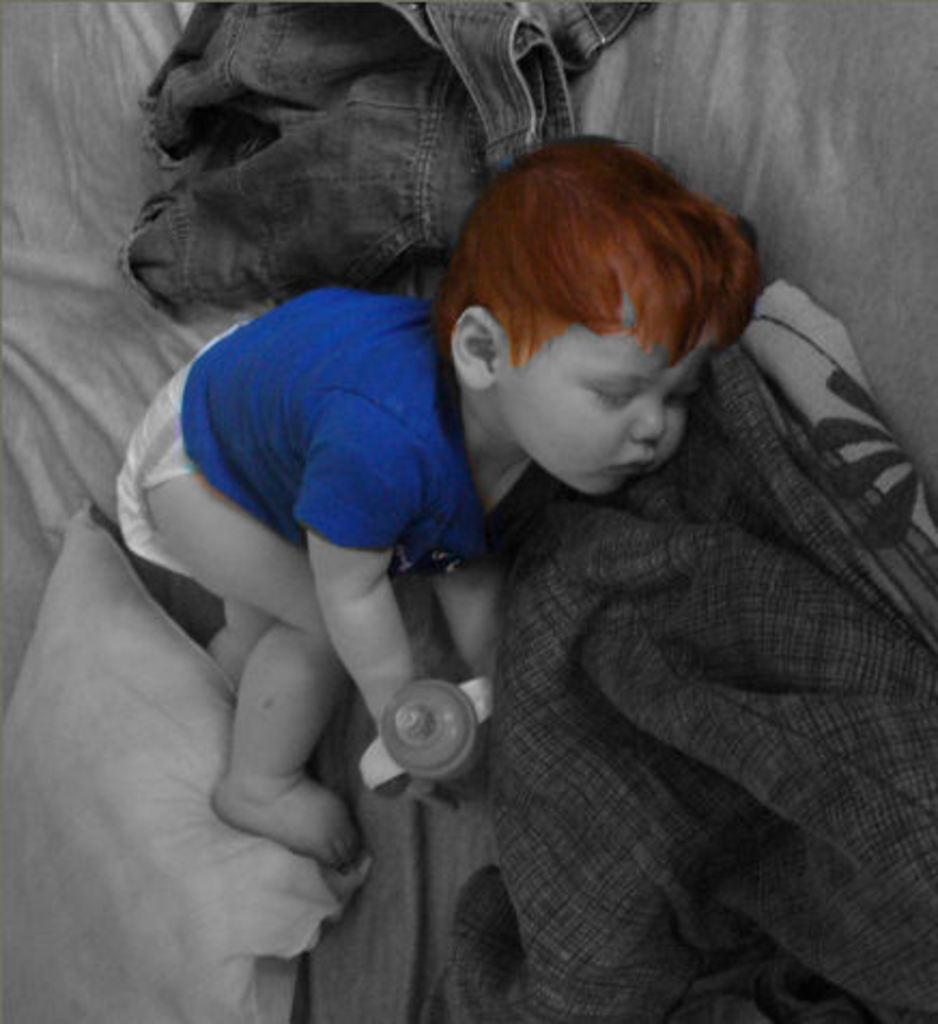What is the main subject of the image? There is a baby in the image. What is the baby wearing? The baby is wearing a blue dress. What color is the baby's hair? The baby has brown hair. What is the baby doing in the image? The baby is sleeping. Where is the baby located in the image? The baby is on a bed. What is near the baby on the bed? There is a pillow near the baby, and there are clothes near the baby. What type of fowl can be seen making a humorous joke in the image? There is no fowl or humor present in the image; it features a sleeping baby on a bed. 